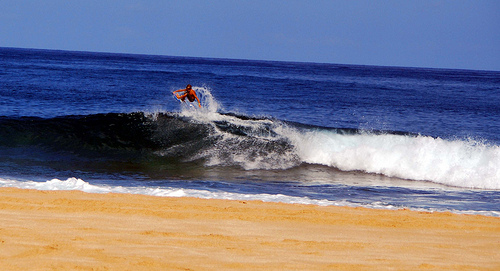Compare the ocean's appearance near the horizon to that which is closer to shore. Far out near the horizon the ocean appears relatively calm and uniform, a stark contrast to the dynamic, rolling waves closer to shore. This tranquility juxtaposed against the surfer's challenge creates a multifaceted narrative of the sea's many personas. 